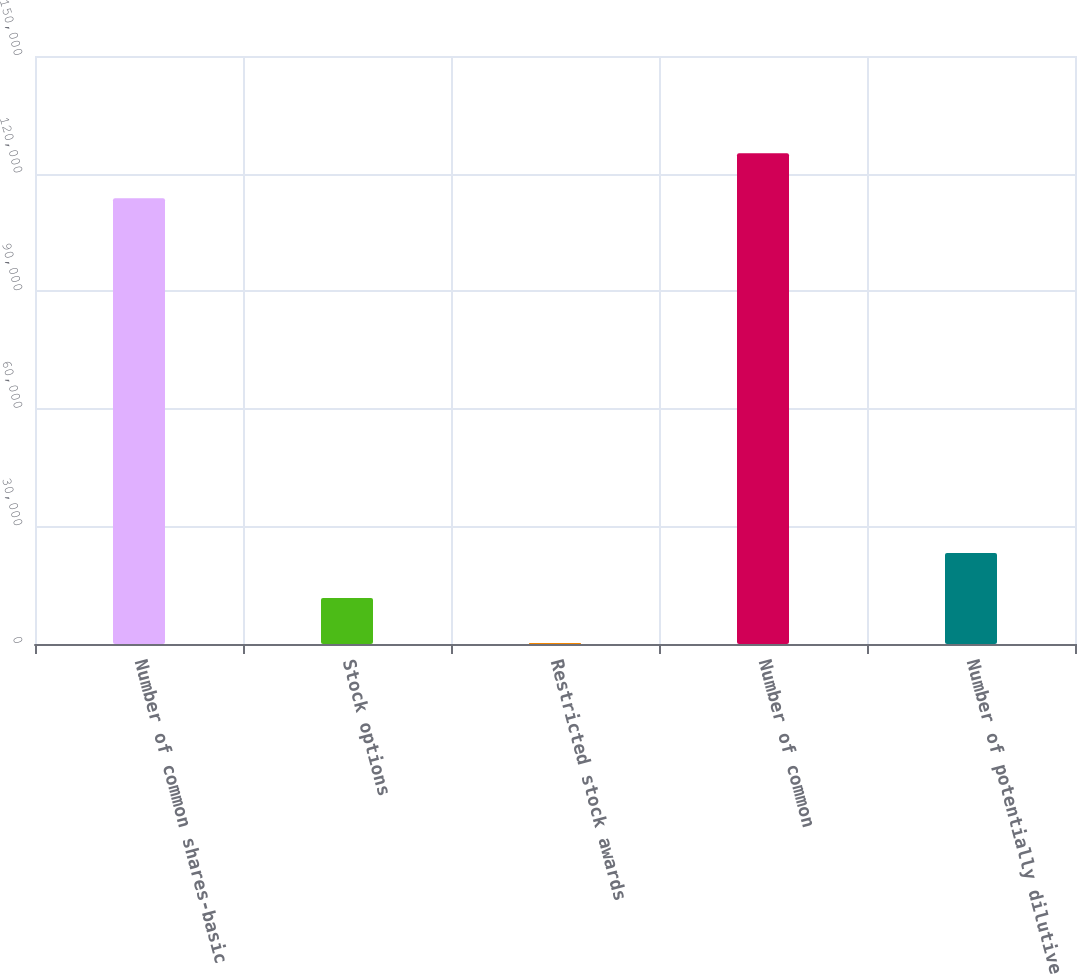<chart> <loc_0><loc_0><loc_500><loc_500><bar_chart><fcel>Number of common shares-basic<fcel>Stock options<fcel>Restricted stock awards<fcel>Number of common<fcel>Number of potentially dilutive<nl><fcel>113728<fcel>11742.5<fcel>285<fcel>125186<fcel>23200<nl></chart> 